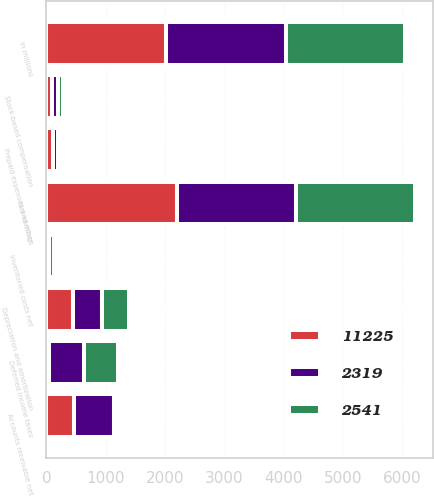Convert chart. <chart><loc_0><loc_0><loc_500><loc_500><stacked_bar_chart><ecel><fcel>in millions<fcel>Net earnings<fcel>Depreciation and amortization<fcel>Stock-based compensation<fcel>Deferred income taxes<fcel>Accounts receivable net<fcel>Inventoried costs net<fcel>Prepaid expenses and other<nl><fcel>2319<fcel>2017<fcel>2015<fcel>475<fcel>94<fcel>603<fcel>677<fcel>36<fcel>81<nl><fcel>11225<fcel>2016<fcel>2200<fcel>456<fcel>93<fcel>36<fcel>461<fcel>15<fcel>110<nl><fcel>2541<fcel>2015<fcel>1990<fcel>467<fcel>99<fcel>572<fcel>30<fcel>80<fcel>43<nl></chart> 